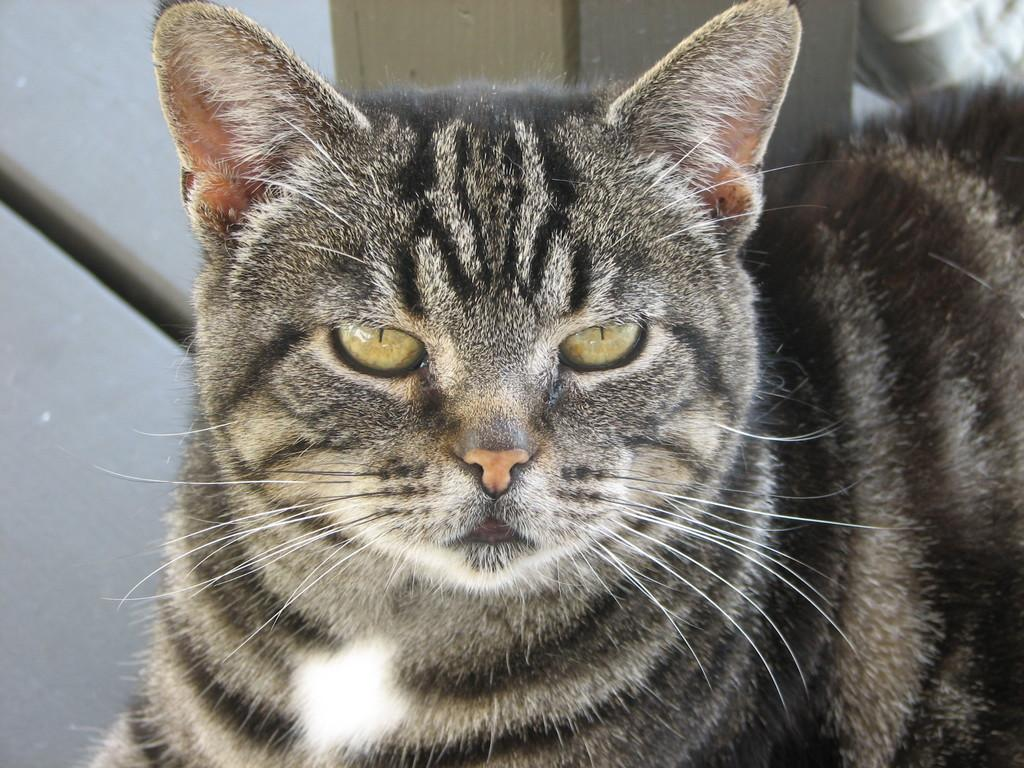What type of animal is in the image? There is a cat in the image. Can you describe the color pattern of the cat? The cat is white and black in color. What feature is common among cats? The cat has whiskers. What can be seen in the background of the image? There is a surface visible in the background of the image. Reasoning: Let's let's think step by step in order to produce the conversation. We start by identifying the main subject of the image, which is the cat. Then, we describe the cat's appearance, focusing on its color pattern and a common feature among cats, which are whiskers. Finally, we mention the background of the image, noting the presence of a surface. Absurd Question/Answer: What type of snakes are being taught in the image? There are no snakes present in the image, and no teaching is taking place. What facial expression does the cat have in the image? The image does not show the cat's facial expression, as it only shows the cat's body and color pattern. What type of snakes are being taught in the image? There are no snakes present in the image, and no teaching is taking place. What facial expression does the cat has in the image? The image does not show the cat's facial expression, as it only shows the cat's body and color pattern. 